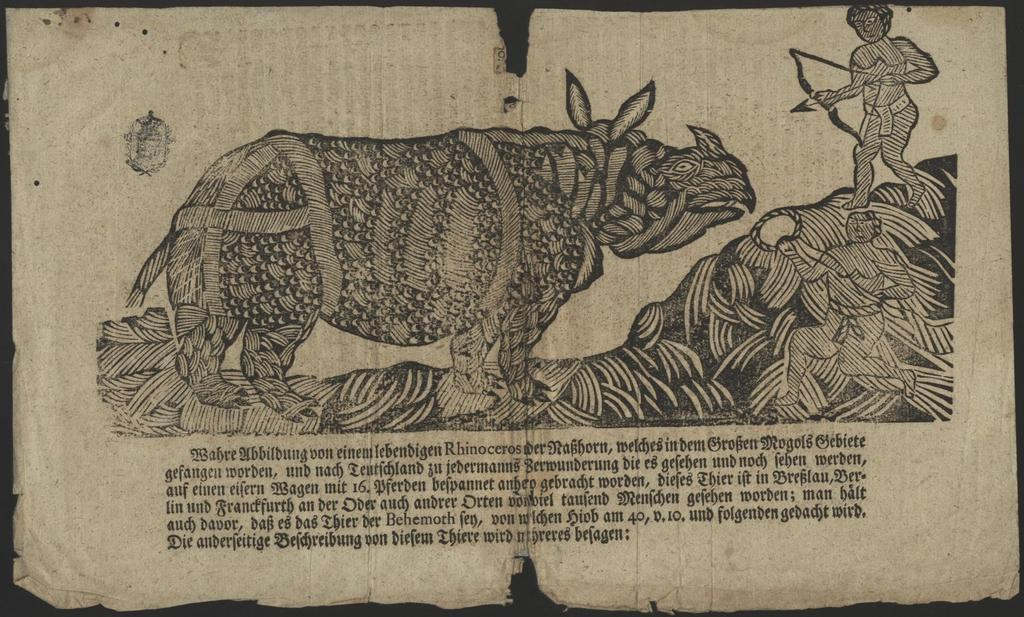What is the main subject in the foreground of the image? There is a paper in the foreground of the image. What is depicted on the paper? The paper has a print of a rhinoceros. What are the two men in the print doing? The two men in the print are attacking the rhinoceros. What are the men holding in the print? The men in the print are holding weapons. Is there any text on the paper? Yes, there is some text at the bottom of the print. Where is the nest of the rhinoceros in the image? There is no nest present in the image, as rhinoceroses do not build nests. 